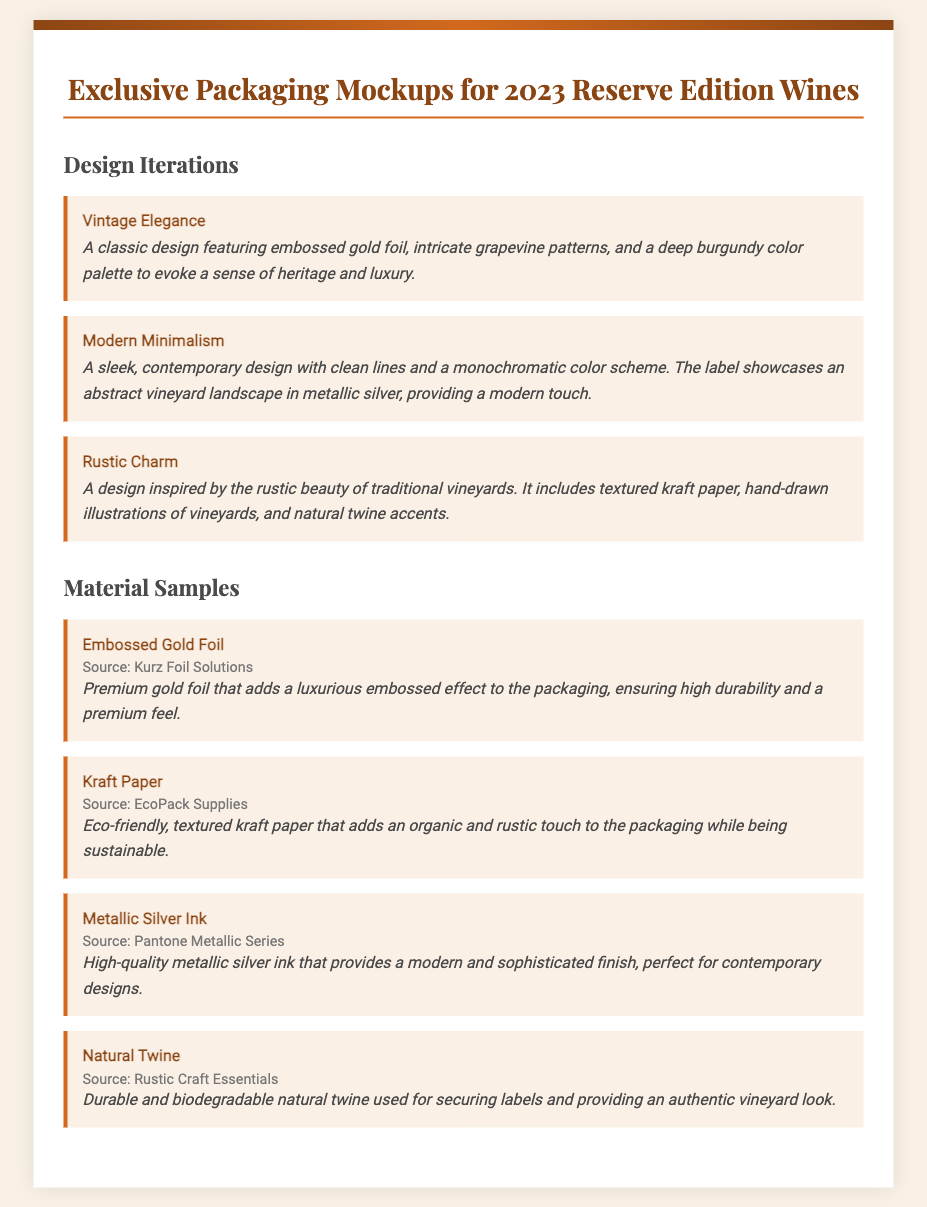What is the title of the document? The title of the document is displayed prominently at the top, indicating the subject matter.
Answer: Exclusive Packaging Mockups for 2023 Reserve Edition Wines How many design iterations are listed? The document provides a section detailing the design iterations, which can be counted.
Answer: 3 What is the first design iteration mentioned? The first design iteration is the top entry in the Design Iterations section.
Answer: Vintage Elegance Which material sample is sourced from EcoPack Supplies? The material sample with this source is described in the Materials Samples section.
Answer: Kraft Paper What type of ink is used in the Modern Minimalism design? The ink type is inferred from the description of the design iteration referring to its characteristics.
Answer: Metallic Silver What provides the rustic charm in the Rustic Charm design? The features listed under the Rustic Charm design provide insight into its distinct elements.
Answer: Textured kraft paper What is the color palette used in the Vintage Elegance design? The color palette is described in the summary of the design iteration.
Answer: Deep burgundy How is the durability of the Embossed Gold Foil described? The description specifies characteristics related to its quality and resistance.
Answer: High durability What is the biodegradable item mentioned in the material samples? The description in the section of material samples identifies which item is biodegradable.
Answer: Natural Twine 